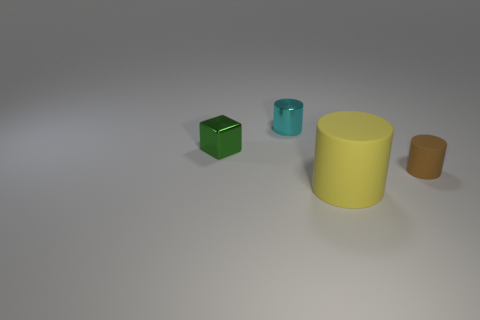Add 4 yellow rubber balls. How many objects exist? 8 Subtract all cubes. How many objects are left? 3 Add 3 tiny rubber cylinders. How many tiny rubber cylinders exist? 4 Subtract 0 blue cubes. How many objects are left? 4 Subtract all small metallic cylinders. Subtract all metal cylinders. How many objects are left? 2 Add 3 small metallic things. How many small metallic things are left? 5 